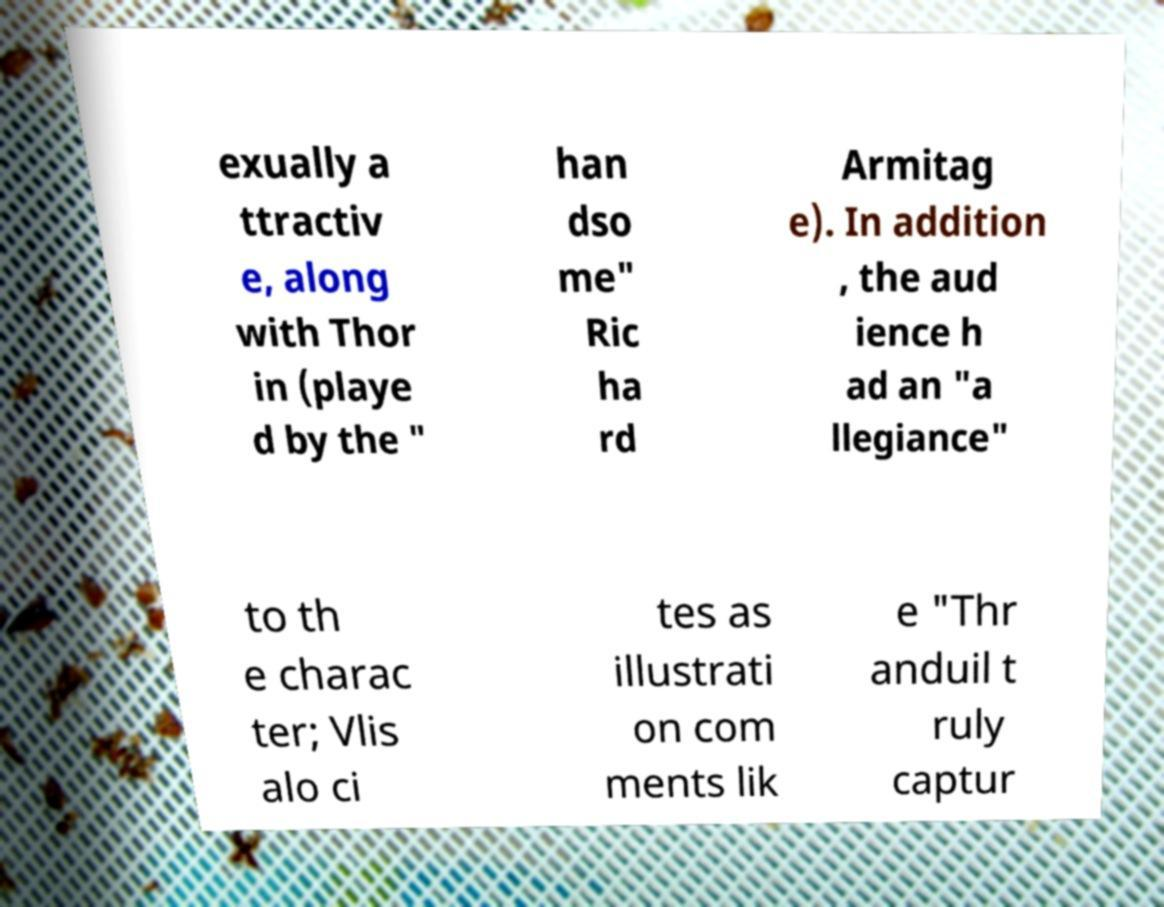For documentation purposes, I need the text within this image transcribed. Could you provide that? exually a ttractiv e, along with Thor in (playe d by the " han dso me" Ric ha rd Armitag e). In addition , the aud ience h ad an "a llegiance" to th e charac ter; Vlis alo ci tes as illustrati on com ments lik e "Thr anduil t ruly captur 